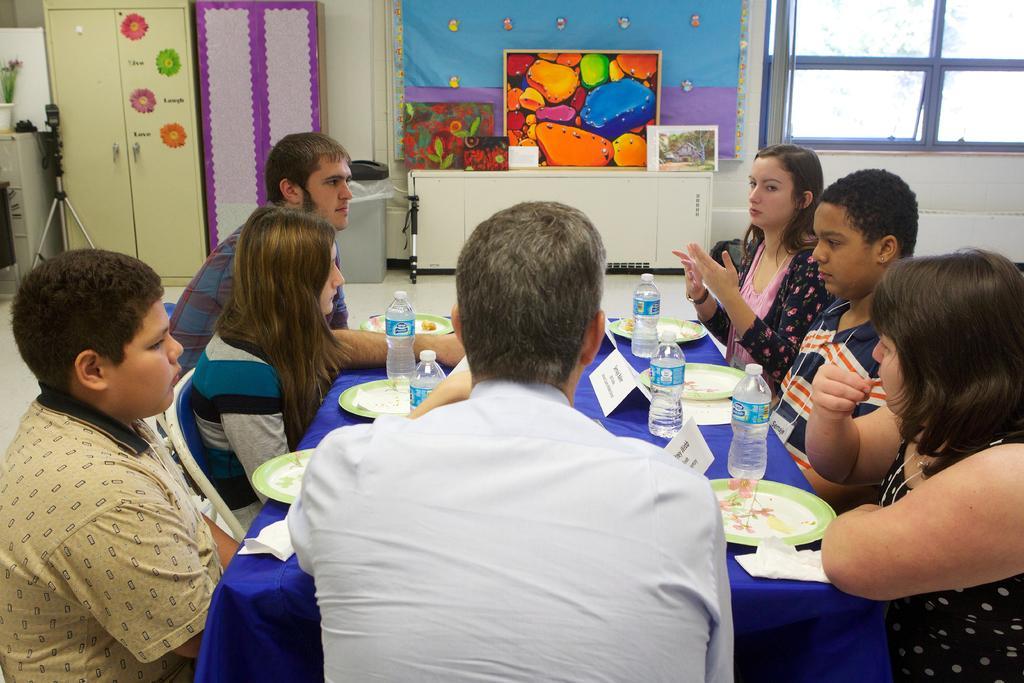Could you give a brief overview of what you see in this image? In this image we can see many persons sitting around the table. On the table we can see plates, tissues, water bottles and name boards. In the background we can see cupboards, camera stand, photo frames, windows, curtain and wall. 